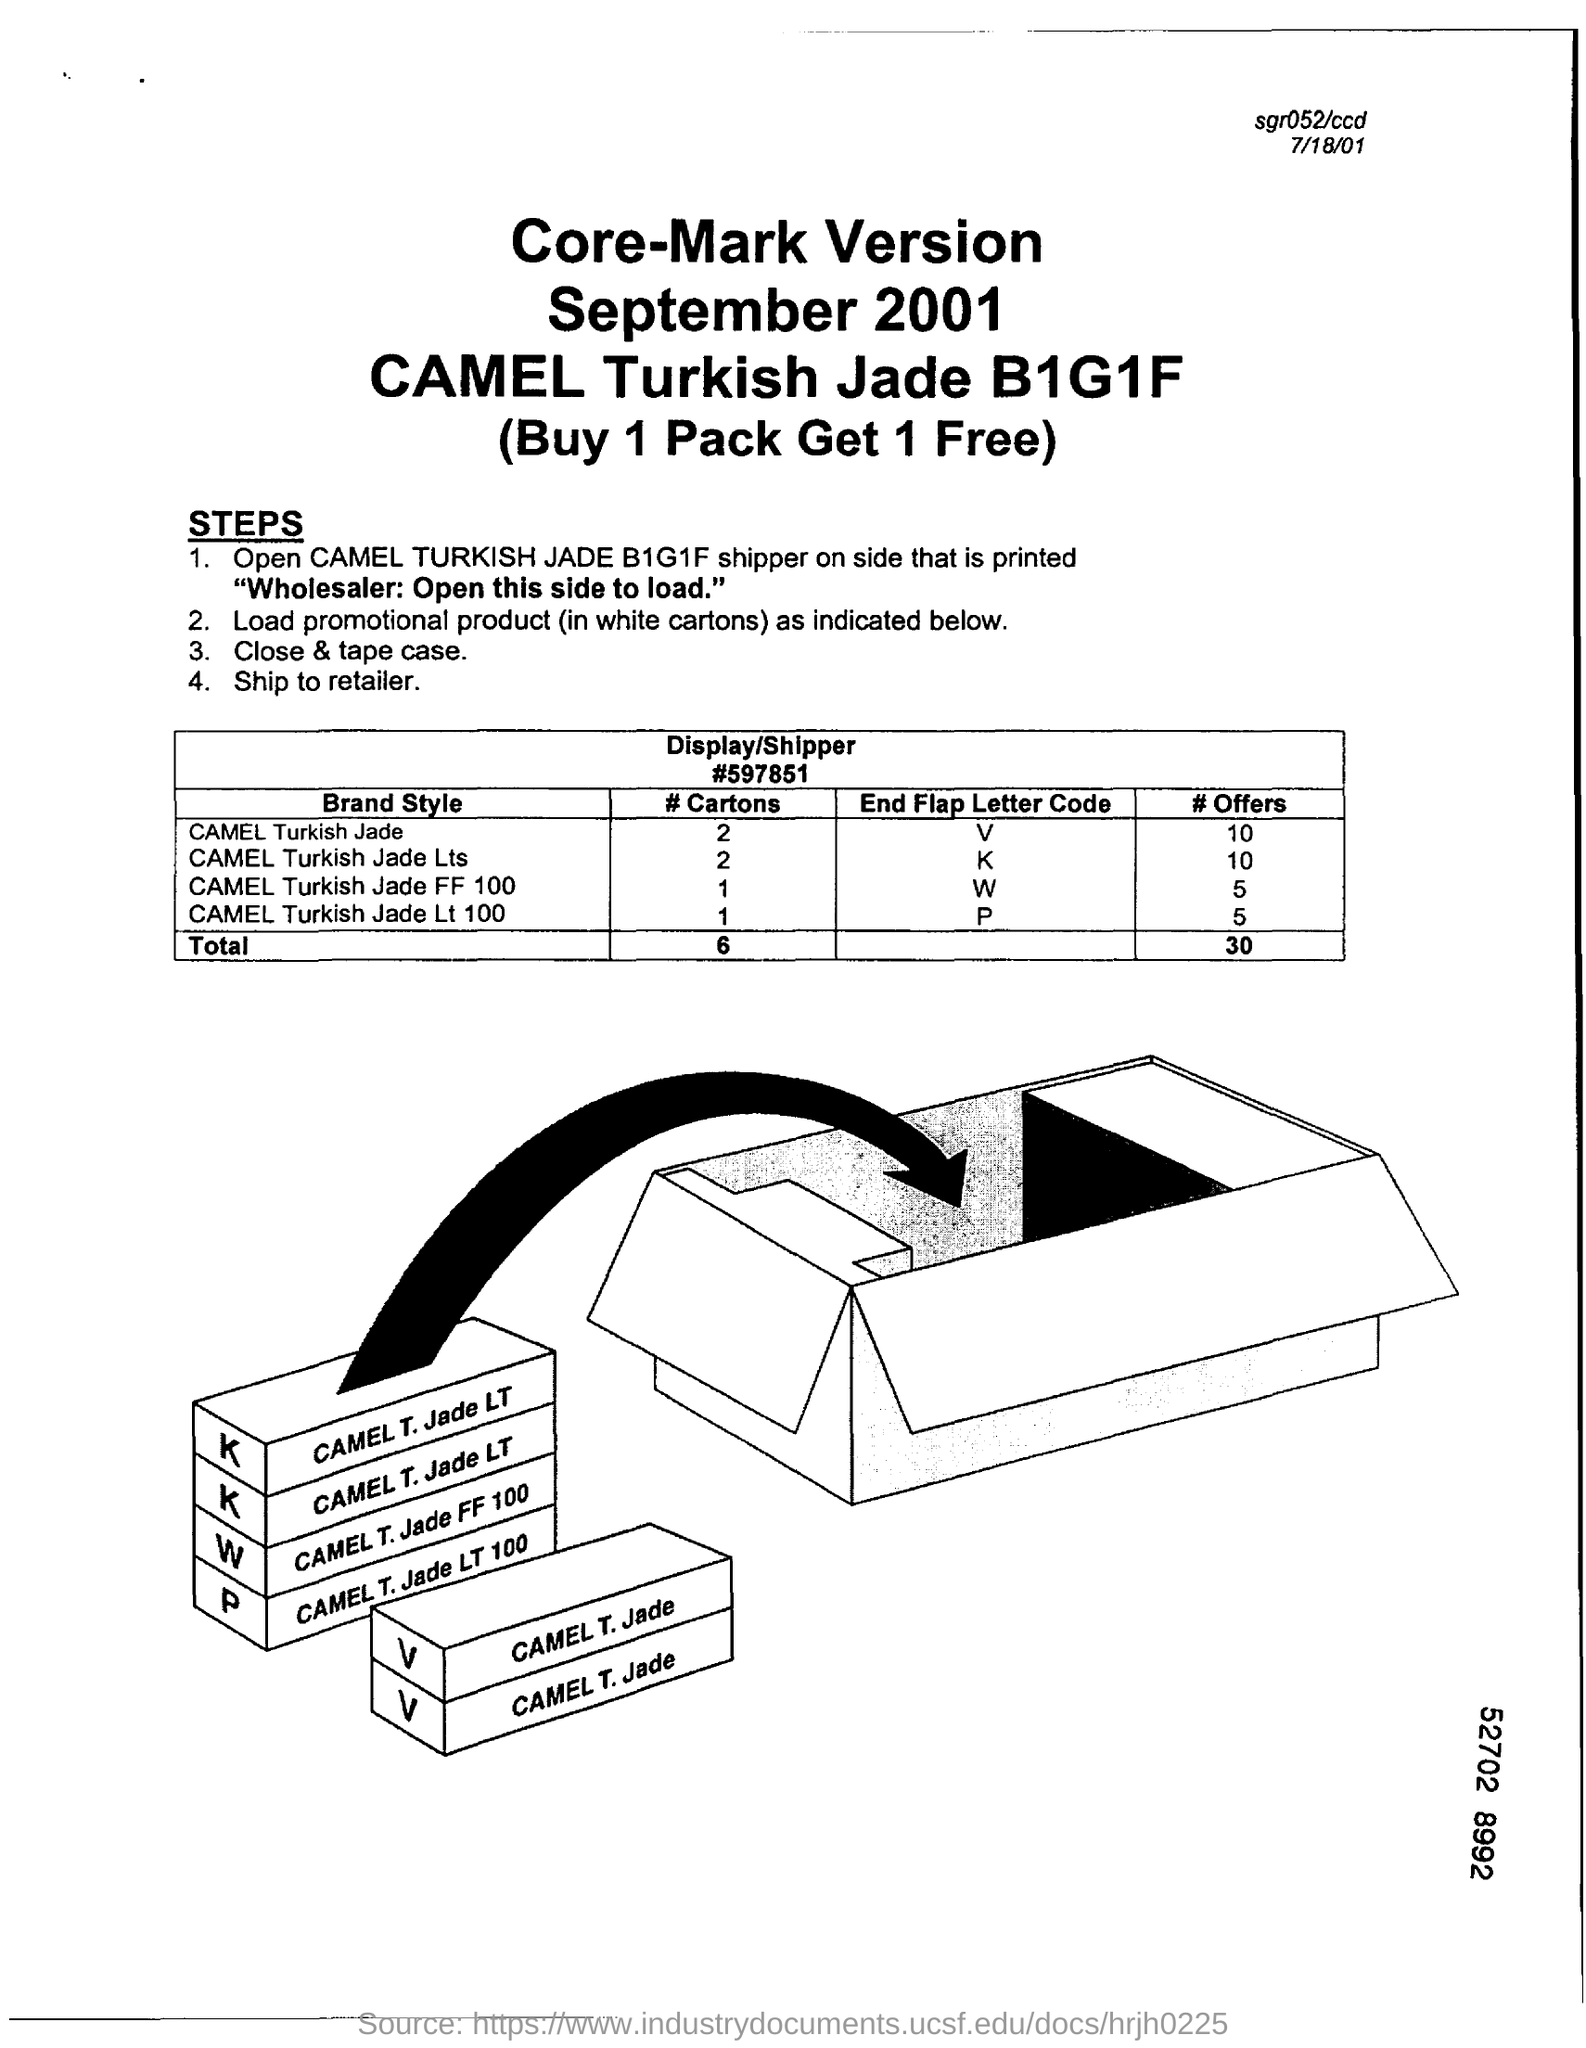Indicate a few pertinent items in this graphic. The brand name is CAMEL. The number of cartons used for Camel Turkish Jade is 2. 